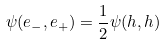<formula> <loc_0><loc_0><loc_500><loc_500>\psi ( e _ { - } , e _ { + } ) = \frac { 1 } { 2 } \psi ( h , h )</formula> 